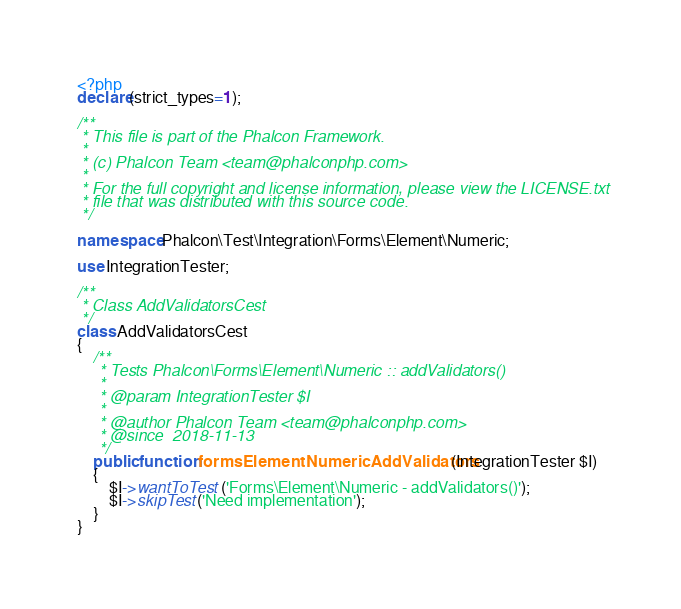Convert code to text. <code><loc_0><loc_0><loc_500><loc_500><_PHP_><?php
declare(strict_types=1);

/**
 * This file is part of the Phalcon Framework.
 *
 * (c) Phalcon Team <team@phalconphp.com>
 *
 * For the full copyright and license information, please view the LICENSE.txt
 * file that was distributed with this source code.
 */

namespace Phalcon\Test\Integration\Forms\Element\Numeric;

use IntegrationTester;

/**
 * Class AddValidatorsCest
 */
class AddValidatorsCest
{
    /**
     * Tests Phalcon\Forms\Element\Numeric :: addValidators()
     *
     * @param IntegrationTester $I
     *
     * @author Phalcon Team <team@phalconphp.com>
     * @since  2018-11-13
     */
    public function formsElementNumericAddValidators(IntegrationTester $I)
    {
        $I->wantToTest('Forms\Element\Numeric - addValidators()');
        $I->skipTest('Need implementation');
    }
}
</code> 